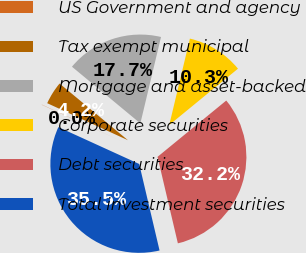Convert chart. <chart><loc_0><loc_0><loc_500><loc_500><pie_chart><fcel>US Government and agency<fcel>Tax exempt municipal<fcel>Mortgage and asset-backed<fcel>Corporate securities<fcel>Debt securities<fcel>Total investment securities<nl><fcel>0.03%<fcel>4.17%<fcel>17.72%<fcel>10.34%<fcel>32.25%<fcel>35.49%<nl></chart> 